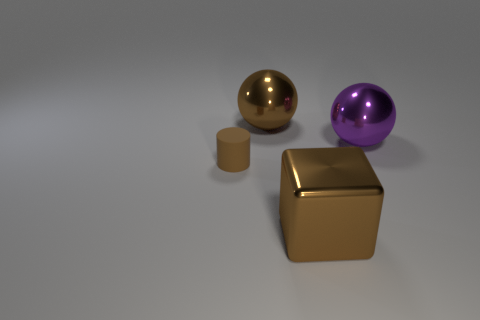Is the color of the rubber cylinder the same as the block?
Make the answer very short. Yes. Is the material of the small brown cylinder left of the large brown block the same as the purple ball that is right of the large block?
Provide a short and direct response. No. Are there any large matte objects?
Make the answer very short. No. There is a brown metal thing that is behind the big cube; is its shape the same as the metallic object on the right side of the big brown shiny block?
Your response must be concise. Yes. Is there a large ball made of the same material as the big cube?
Make the answer very short. Yes. Does the sphere that is left of the purple shiny sphere have the same material as the large purple object?
Keep it short and to the point. Yes. Are there more things that are behind the matte cylinder than big metal things that are on the left side of the big purple object?
Make the answer very short. No. The cube that is the same size as the purple sphere is what color?
Ensure brevity in your answer.  Brown. Is there a block that has the same color as the small rubber cylinder?
Ensure brevity in your answer.  Yes. There is a object that is to the left of the big brown metal sphere; does it have the same color as the large thing that is in front of the purple metallic ball?
Your response must be concise. Yes. 